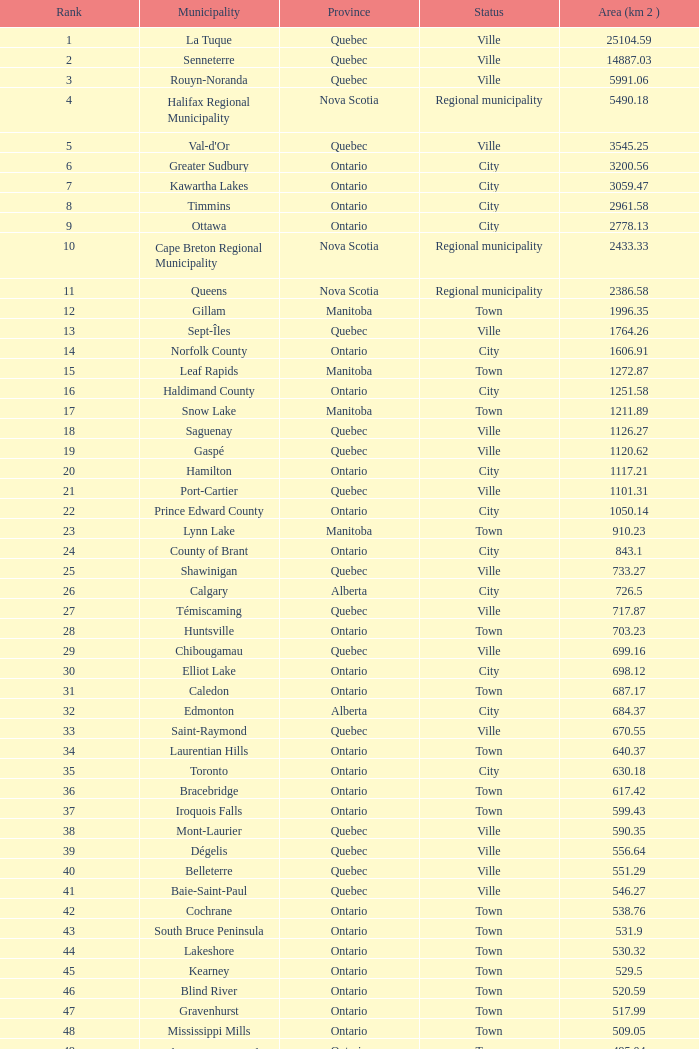What is the total Rank that has a Municipality of Winnipeg, an Area (KM 2) that's larger than 464.01? None. 